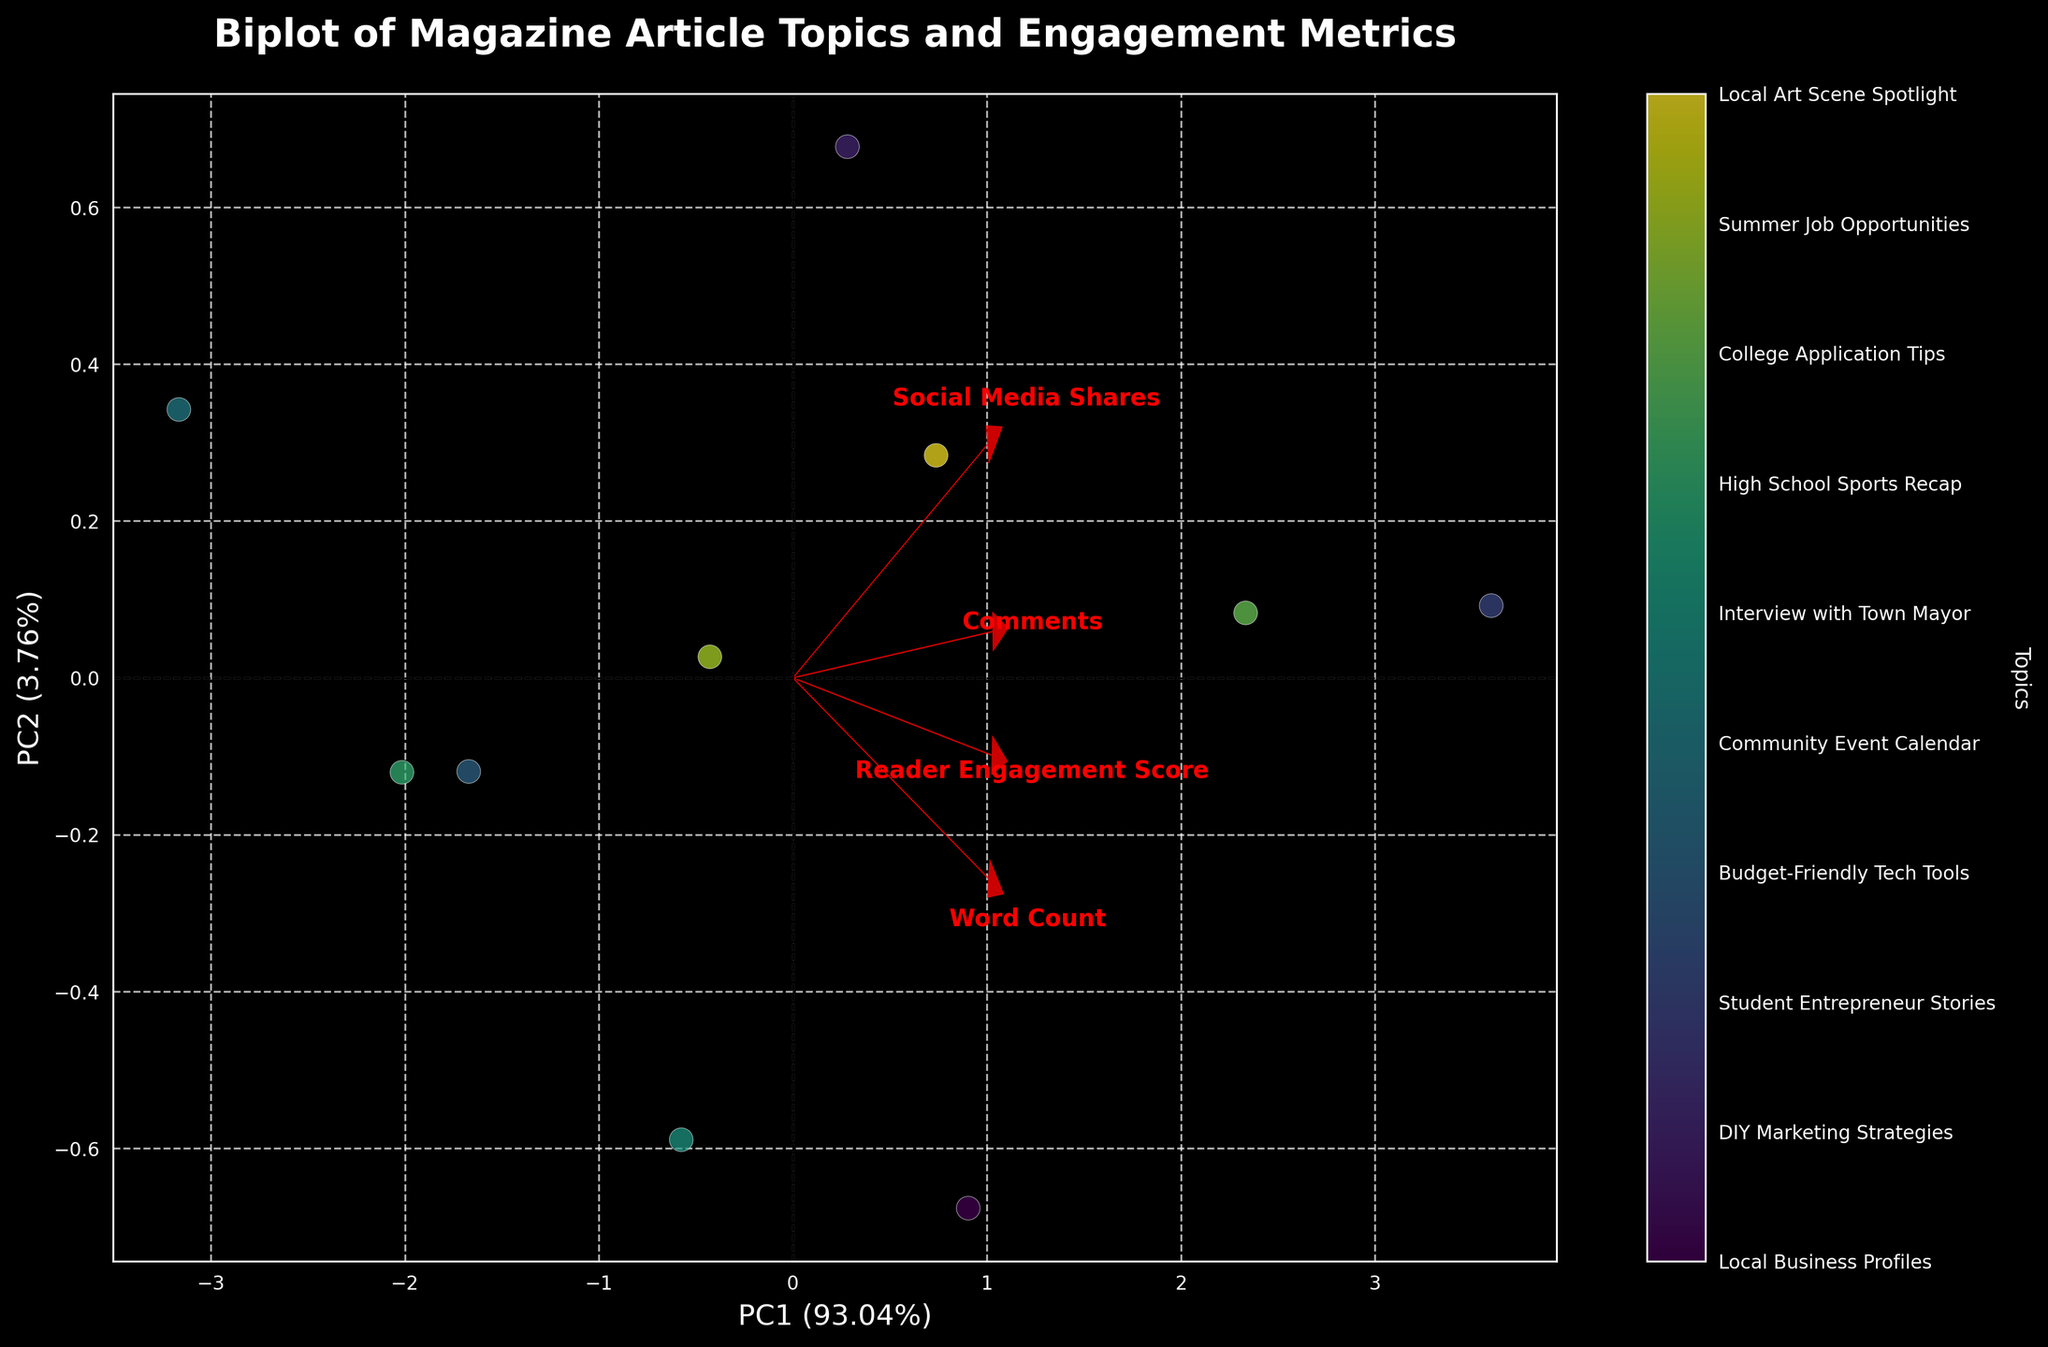What is the title of the figure? The title of the figure can be found at the top, and it provides an overview of what the figure represents.
Answer: Biplot of Magazine Article Topics and Engagement Metrics What do PC1 and PC2 stand for on the axes? The axes labels indicate that PC1 stands for Principal Component 1 and PC2 stands for Principal Component 2.
Answer: Principal Component 1 and Principal Component 2 How many article topics are represented in the biplot? Count the number of distinct points in the scatter plot; each point represents a different article topic.
Answer: 10 Which feature has the highest loading on PC1? Compare the arrows representing the loadings for each feature along the x-axis, which represents PC1.
Answer: Word Count What is the relationship between 'Social Media Shares' and PC2? Observe the direction and length of the arrow for 'Social Media Shares' compared to the vertical axis (PC2).
Answer: Positive correlation Which two article topics have the most similar PCA scores? Identify the two points on the scatter plot that are closest to each other in terms of both PC1 and PC2 values.
Answer: Interview with Town Mayor and Local Art Scene Spotlight Which topic is more associated with 'Comments': 'Local Business Profiles' or 'Community Event Calendar'? Locate the points corresponding to these topics and compare their positions relative to the arrow for 'Comments'.
Answer: Local Business Profiles What percentage of the total variance is explained by PC1 and PC2 combined? Add the explained variance ratios provided next to the axes labels for PC1 and PC2.
Answer: (check the figure for exact values) % How are 'Reader Engagement Score' and 'Comments' related according to the biplot? Observe the direction of the arrows for 'Reader Engagement Score' and 'Comments' and note if they point in similar or different directions.
Answer: Positively correlated What can you infer about the topic 'Student Entrepreneur Stories' based on its position in the biplot? Examine where 'Student Entrepreneur Stories' is located in relation to the arrows for 'Reader Engagement Score', 'Comments', etc. It appears to be positively associated with higher 'Reader Engagement Score' and 'Comments'.
Answer: High reader engagement and comments 